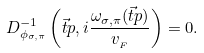<formula> <loc_0><loc_0><loc_500><loc_500>D _ { \phi _ { \sigma , \pi } } ^ { - 1 } \left ( \vec { t } { p } , i \frac { \omega _ { \sigma , \pi } ( \vec { t } { p } ) } { v _ { _ { F } } } \right ) = 0 .</formula> 